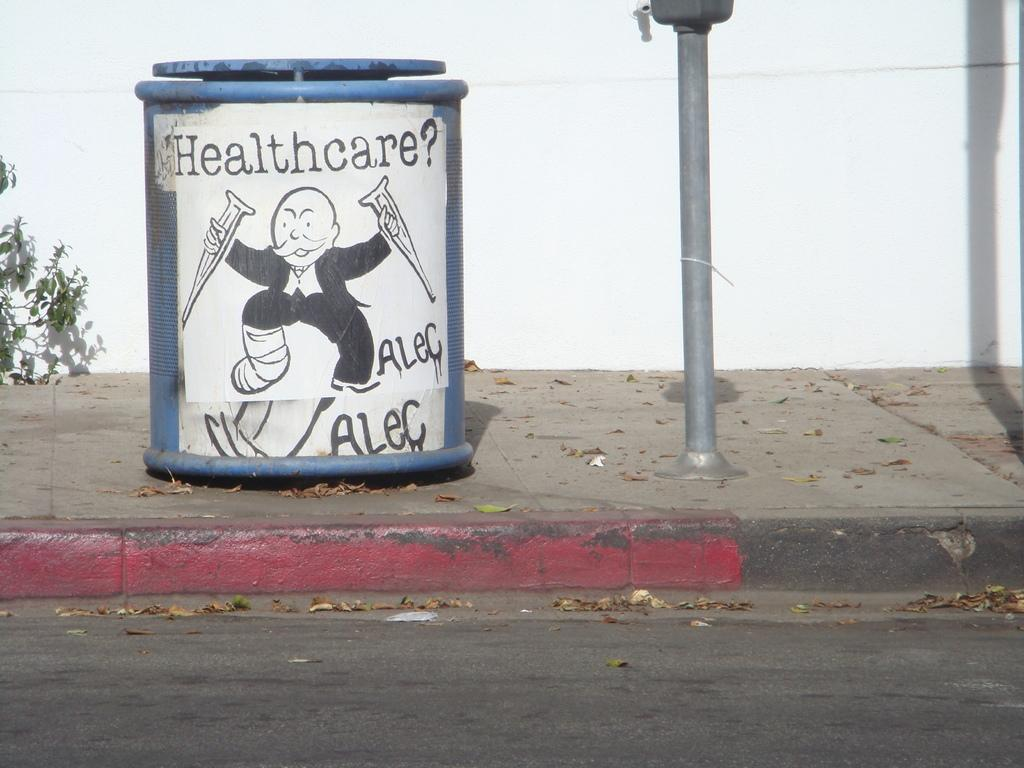<image>
Render a clear and concise summary of the photo. A trash can is branded with a poster that reads "Healthcare?" 